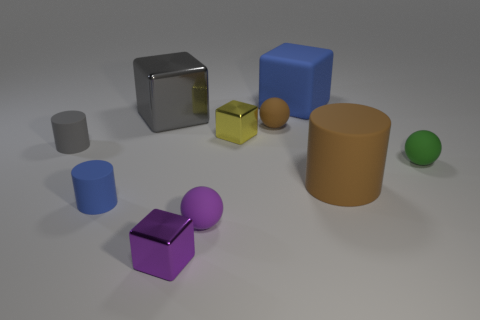What number of other things are there of the same shape as the small yellow thing?
Keep it short and to the point. 3. What color is the rubber object that is both to the left of the small brown matte sphere and right of the tiny blue rubber thing?
Provide a short and direct response. Purple. Are there any other things that are the same size as the gray metallic object?
Your response must be concise. Yes. Do the metallic thing behind the small brown matte thing and the large rubber block have the same color?
Your response must be concise. No. What number of cylinders are either tiny purple matte objects or small green things?
Your answer should be very brief. 0. What shape is the gray thing on the left side of the tiny blue rubber cylinder?
Your response must be concise. Cylinder. What color is the thing that is in front of the tiny rubber sphere left of the small shiny block that is behind the gray matte cylinder?
Your response must be concise. Purple. Is the material of the large brown cylinder the same as the tiny gray cylinder?
Make the answer very short. Yes. What number of gray objects are tiny metal things or large cylinders?
Make the answer very short. 0. How many yellow metal objects are in front of the tiny yellow metal block?
Ensure brevity in your answer.  0. 